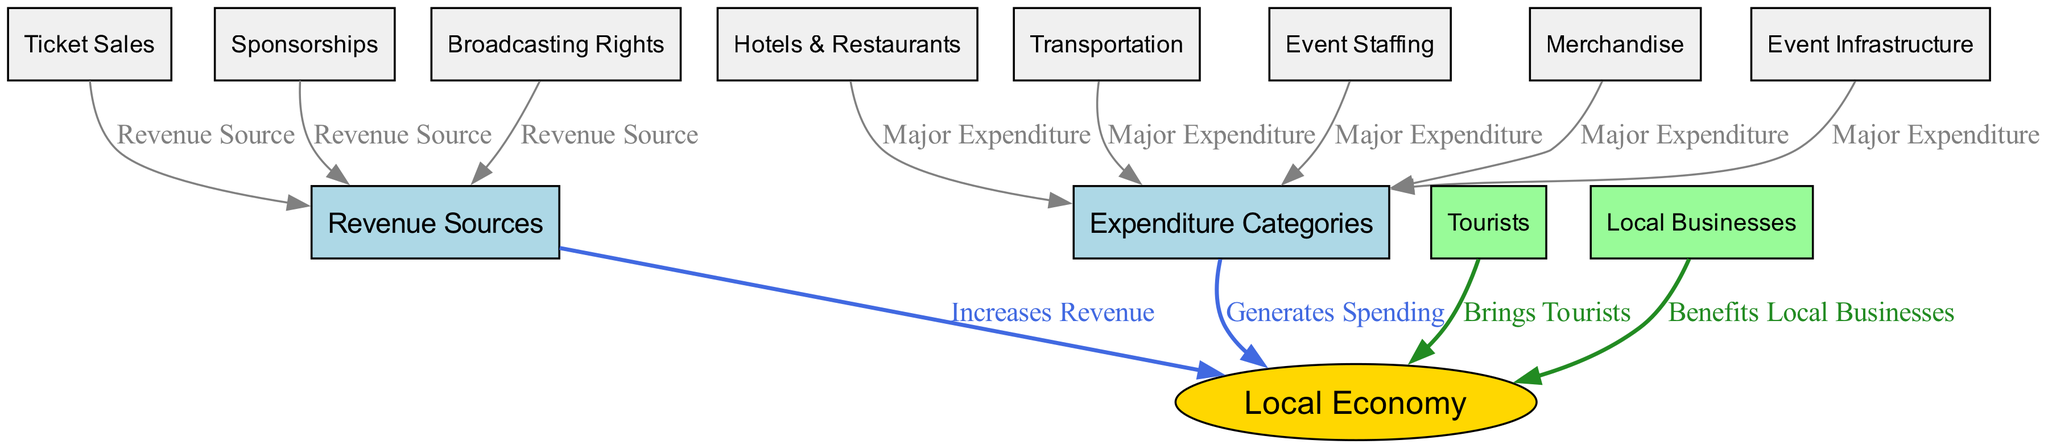What are the major revenue sources in the local economy? Based on the diagram, the major revenue sources are represented by the nodes connected to 'revenueSources' which include 'ticketSales', 'sponsorships', and 'broadcastingRights'.
Answer: Ticket Sales, Sponsorships, Broadcasting Rights How many expenditure categories are shown in the diagram? The diagram lists five expenditure categories which are represented by the nodes connected to 'expenditureCategories': 'hotelsRestaiurants', 'transportation', 'eventStaffing', 'merchandise', and 'eventInfrastructure'.
Answer: 5 What relationship does 'localBusinesses' have with 'localEconomy'? The diagram shows a direct relationship where 'localBusinesses' benefits the 'localEconomy', indicated by the edge labeled 'Benefits Local Businesses' pointing to 'localEconomy'.
Answer: Benefits Local Businesses Which expenditure category is labeled as 'Major Expenditure'? The nodes 'hotelsRestaiurants', 'transportation', 'eventStaffing', 'merchandise', and 'eventInfrastructure', all have edges labeled 'Major Expenditure' pointing to 'expenditureCategories', indicating they are major expenditures.
Answer: Hotels & Restaurants, Transportation, Event Staffing, Merchandise, Event Infrastructure How do tourists impact the local economy? According to the diagram, tourists bring income into the local economy, as represented by the edge labeled 'Brings Tourists' which connects 'tourists' to 'localEconomy'.
Answer: Brings Tourists What is the main source of revenue that increases the local economy? From the diagram, all sources linked to 'revenueSources' contribute to the increase in the 'localEconomy', specifically noted as an increase in revenue.
Answer: Increases Revenue What do Event Staffing expenses contribute to the local economy? The diagram shows that 'eventStaffing' is categorized as a 'Major Expenditure' and it generates spending in the local economy by connecting to 'localEconomy' through 'expenditureCategories'.
Answer: Generates Spending Which nodes are connected to 'expenditureCategories'? The nodes that are connected to 'expenditureCategories' include 'hotelsRestaiurants', 'transportation', 'eventStaffing', 'merchandise', and 'eventInfrastructure', all showing major expenditures.
Answer: Hotels & Restaurants, Transportation, Event Staffing, Merchandise, Event Infrastructure What type of diagram does this represent? The structure, where nodes represent entities and edges indicate relationships of increases or spending between them, classifies this as a Textbook Diagram focused on the economic impacts in local economies.
Answer: Textbook Diagram 